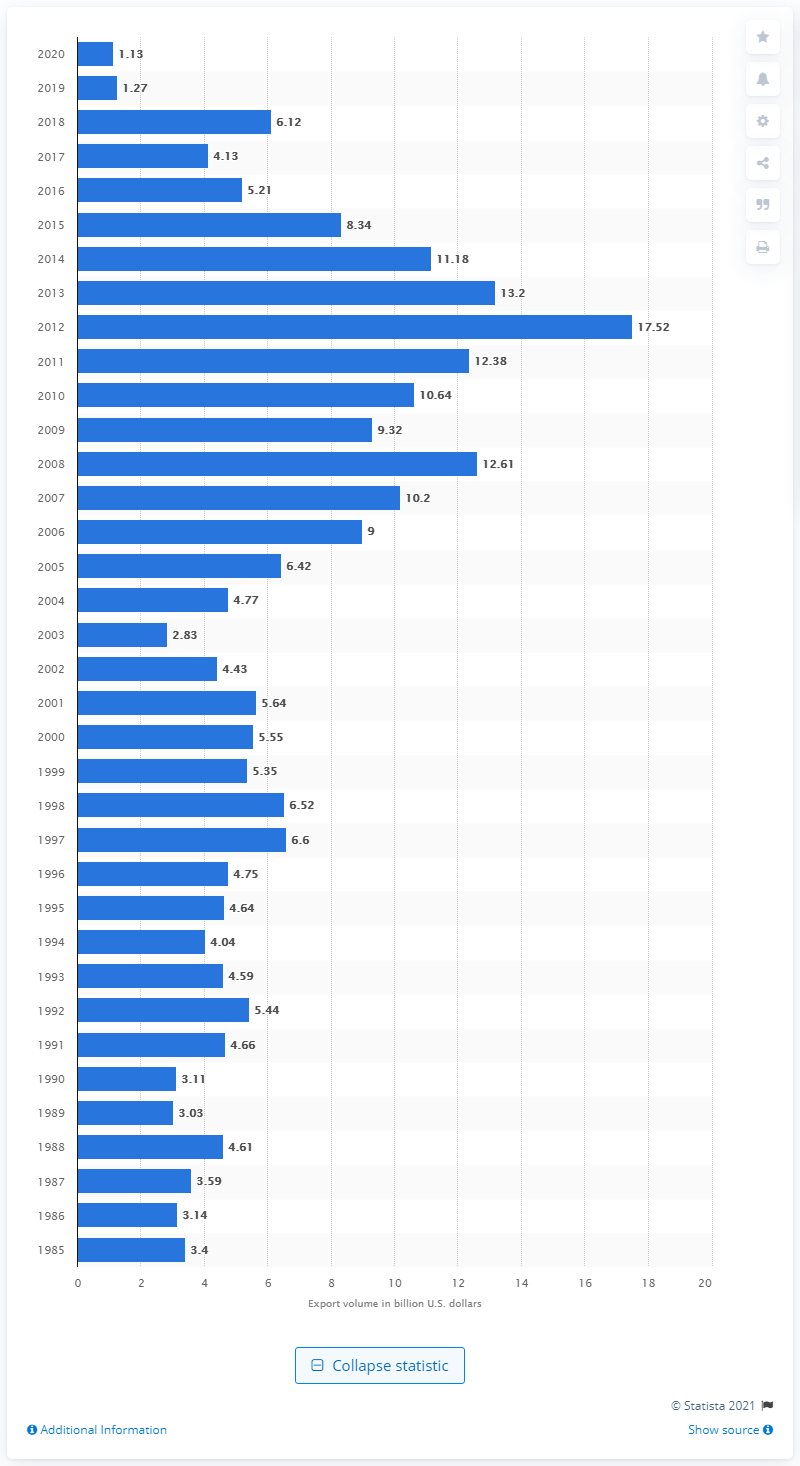Indicate a few pertinent items in this graphic. In 2020, the value of U.S. exports to Venezuela was $1.13 billion. 